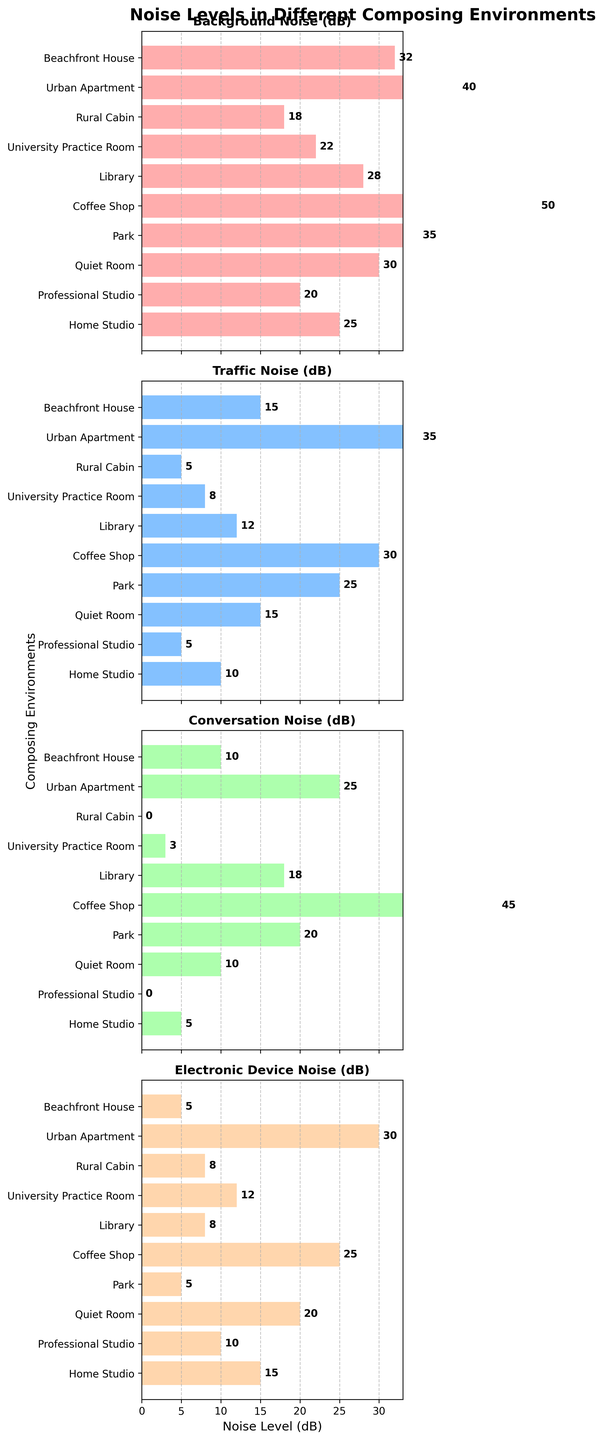How many composing environments are analyzed in the figure? Count the number of rows or bar clusters in any subplot; each bar represents an environment.
Answer: 10 What is the title of the figure? Read the text at the top of the figure.
Answer: Noise Levels in Different Composing Environments Which environment has the highest level of background noise? Identify the highest bar in the "Background Noise (dB)" subplot and match it to the corresponding environment.
Answer: Coffee Shop What is the average traffic noise level across all environments? Sum all traffic noise values and divide by the number of environments (10). Calculation: (10 + 5 + 15 + 25 + 30 + 12 + 8 + 5 + 35 + 15) / 10 = 16
Answer: 16 In which environment is the conversation noise the lowest? Identify the shortest bar in the "Conversation Noise (dB)" subplot and match it to the corresponding environment.
Answer: Professional Studio Which two environments have the same level of background noise? Find any two bars of the same height in "Background Noise (dB)" subplot.
Answer: Home Studio and Library What’s the difference between the urban apartment's background noise and rural cabin's background noise? Subtract the latter's value from the former's value. Calculation: 40 - 18 = 22
Answer: 22 In which environment is the electronic device noise the highest? Identify the highest bar in the "Electronic Device Noise (dB)" subplot and match it to the corresponding environment.
Answer: Coffee Shop Does any environment have zero traffic noise? If so, which one? Look for any zero-value bar in the "Traffic Noise (dB)" subplot.
Answer: Professional Studio and Rural Cabin What's the sum of conversation noise levels for Park and Beachfront House? Add the conversation noise values of both environments. Calculation: 20 + 10 = 30
Answer: 30 